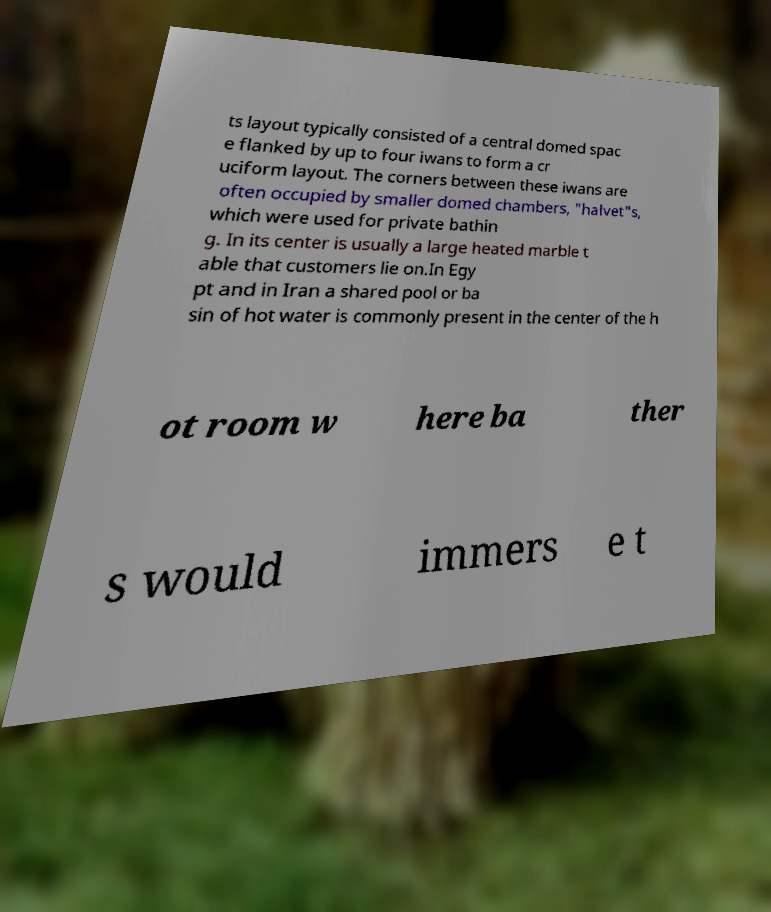For documentation purposes, I need the text within this image transcribed. Could you provide that? ts layout typically consisted of a central domed spac e flanked by up to four iwans to form a cr uciform layout. The corners between these iwans are often occupied by smaller domed chambers, "halvet"s, which were used for private bathin g. In its center is usually a large heated marble t able that customers lie on.In Egy pt and in Iran a shared pool or ba sin of hot water is commonly present in the center of the h ot room w here ba ther s would immers e t 